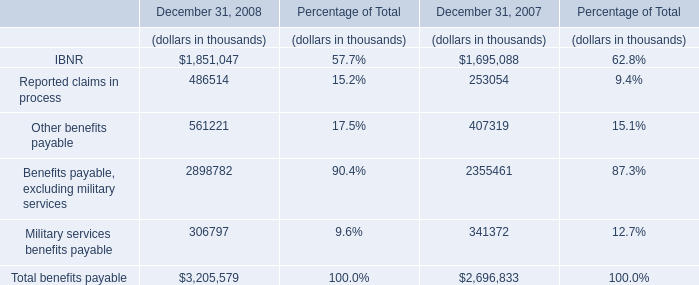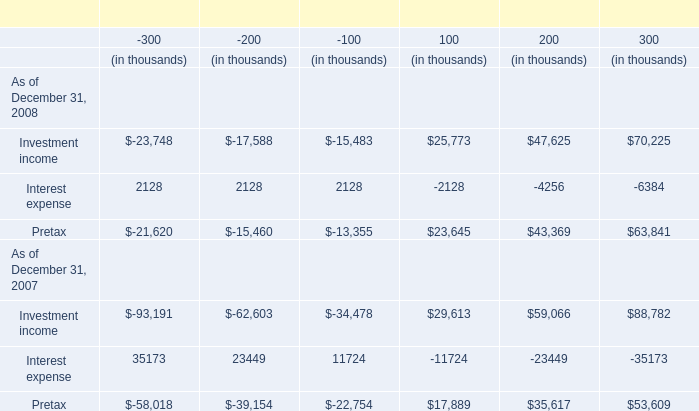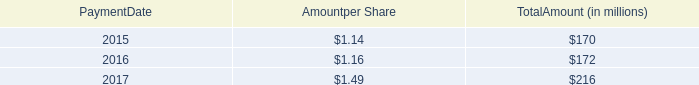What was the sum of -300 without those Increase (decrease) in pretax earnings givenan interest rate decrease of X basis points smaller than 0, in 2008? (in thousand) 
Computations: ((2128 + 2128) + 2128)
Answer: 6384.0. 